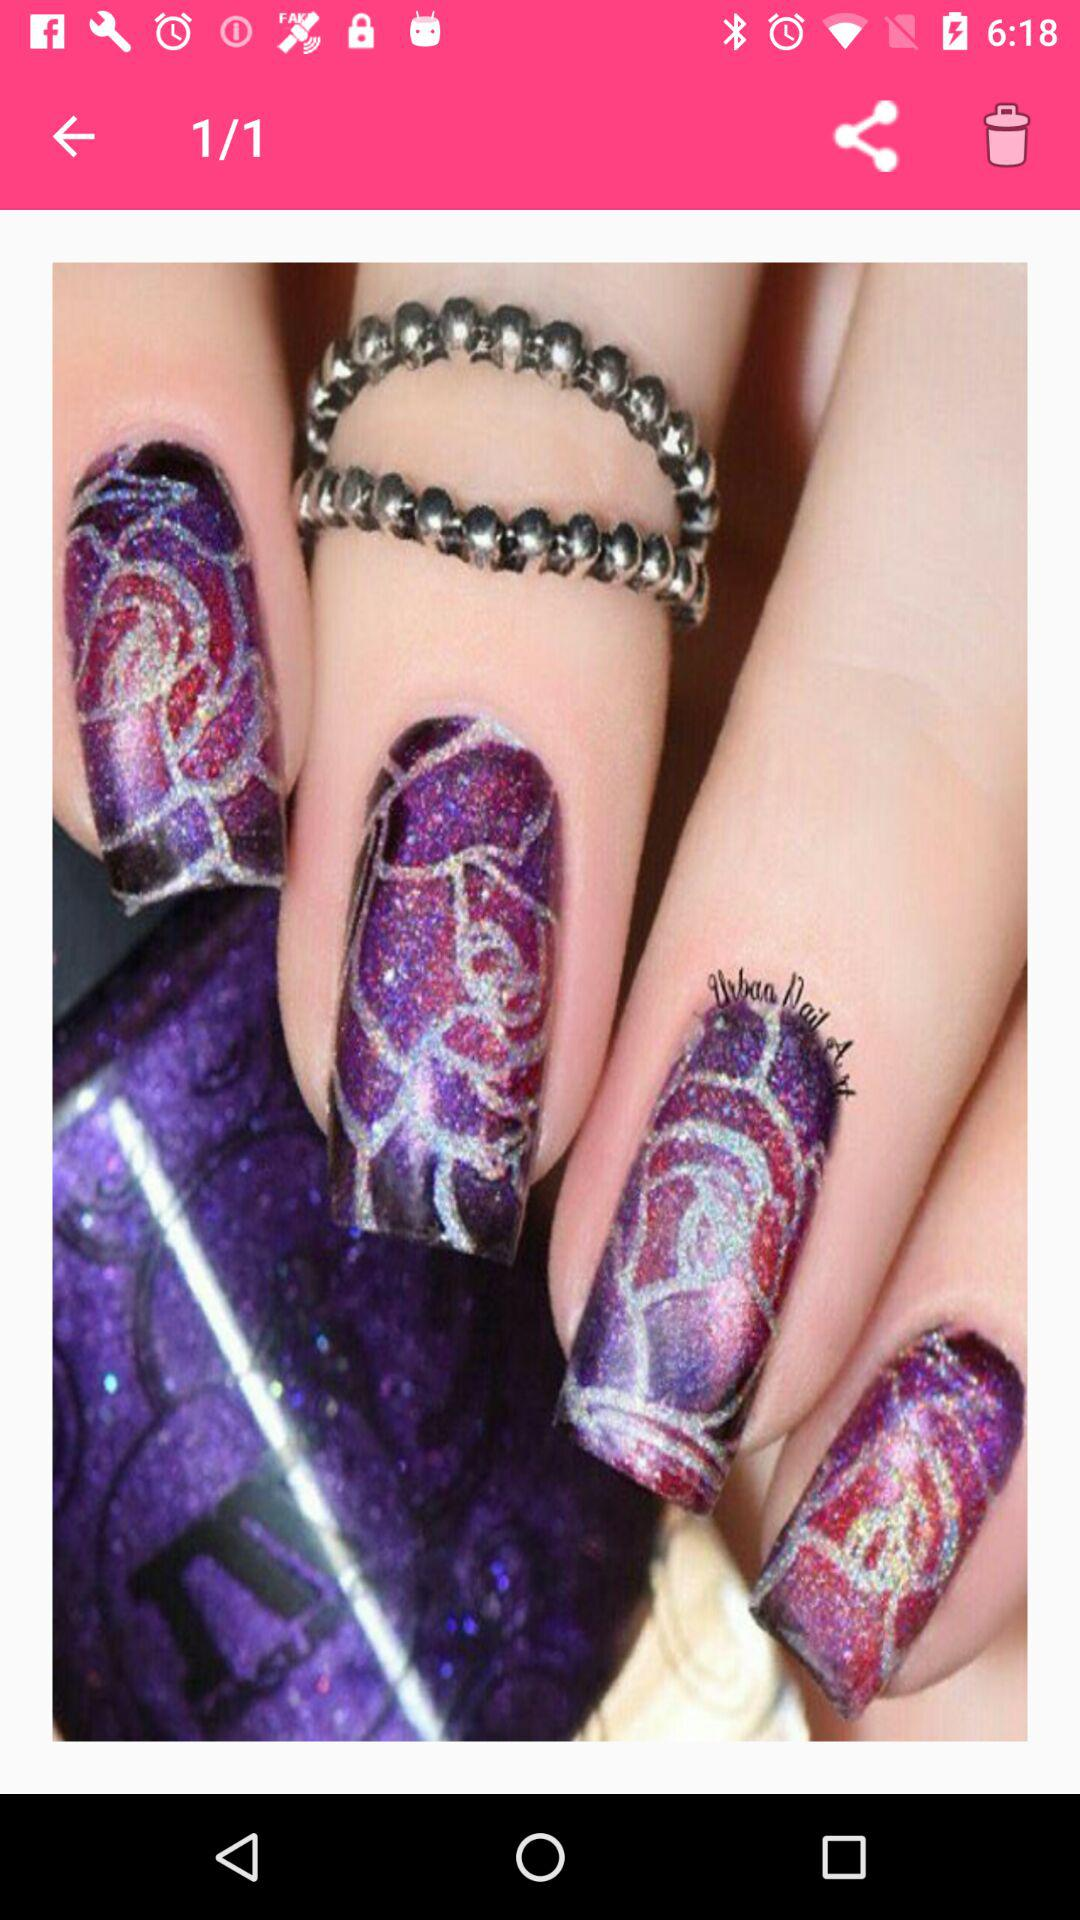Which image number is showing right now? The image number that is showing right now is 1. 